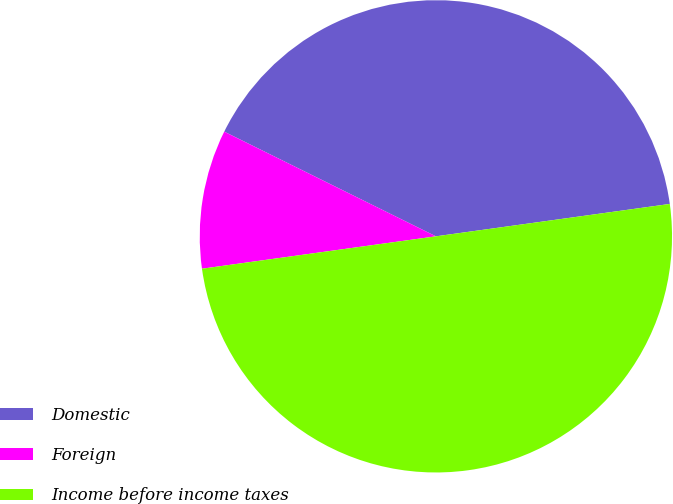Convert chart. <chart><loc_0><loc_0><loc_500><loc_500><pie_chart><fcel>Domestic<fcel>Foreign<fcel>Income before income taxes<nl><fcel>40.5%<fcel>9.5%<fcel>50.0%<nl></chart> 